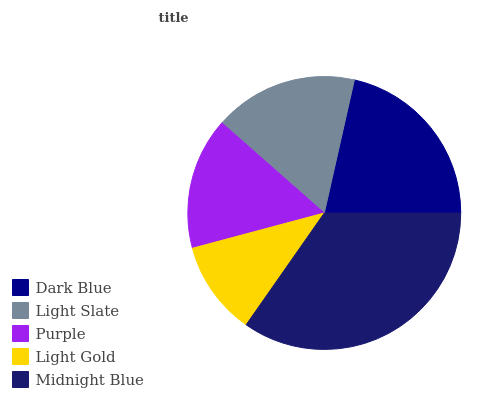Is Light Gold the minimum?
Answer yes or no. Yes. Is Midnight Blue the maximum?
Answer yes or no. Yes. Is Light Slate the minimum?
Answer yes or no. No. Is Light Slate the maximum?
Answer yes or no. No. Is Dark Blue greater than Light Slate?
Answer yes or no. Yes. Is Light Slate less than Dark Blue?
Answer yes or no. Yes. Is Light Slate greater than Dark Blue?
Answer yes or no. No. Is Dark Blue less than Light Slate?
Answer yes or no. No. Is Light Slate the high median?
Answer yes or no. Yes. Is Light Slate the low median?
Answer yes or no. Yes. Is Purple the high median?
Answer yes or no. No. Is Midnight Blue the low median?
Answer yes or no. No. 